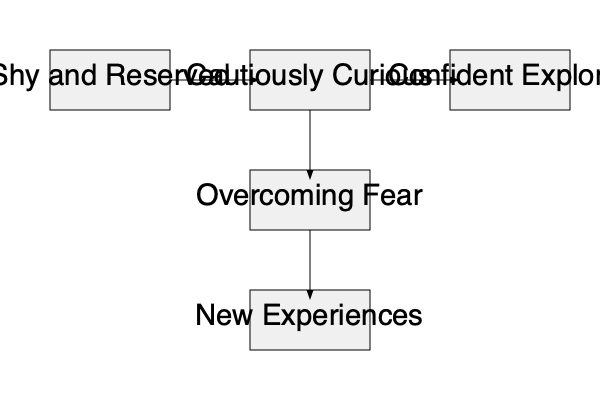Analyze the flowchart depicting a character's development. What key transition occurs between the "Cautiously Curious" and "Confident Explorer" stages, and how might this impact the character's actions in the story? To answer this question, let's break down the character development flowchart:

1. The character starts as "Shy and Reserved."
2. They progress to "Cautiously Curious," indicating some growth.
3. Between "Cautiously Curious" and "Confident Explorer," we see two intermediate stages:
   a. "Overcoming Fear"
   b. "New Experiences"
4. These intermediate stages represent the key transition.
5. "Overcoming Fear" suggests the character is confronting their anxieties or insecurities.
6. "New Experiences" implies the character is stepping out of their comfort zone.
7. This transition leads to the "Confident Explorer" stage, showing significant personal growth.

The impact on the character's actions in the story could be:
- Increased willingness to take risks
- More active participation in plot events
- Improved ability to face challenges
- Development of new skills or relationships
- A shift in their role within the story, possibly becoming more of a leader or initiator

This transition is crucial for character arc and plot development, potentially driving the story forward and creating more engaging conflicts and resolutions.
Answer: Overcoming fear and gaining new experiences, leading to increased risk-taking and active participation in the story. 